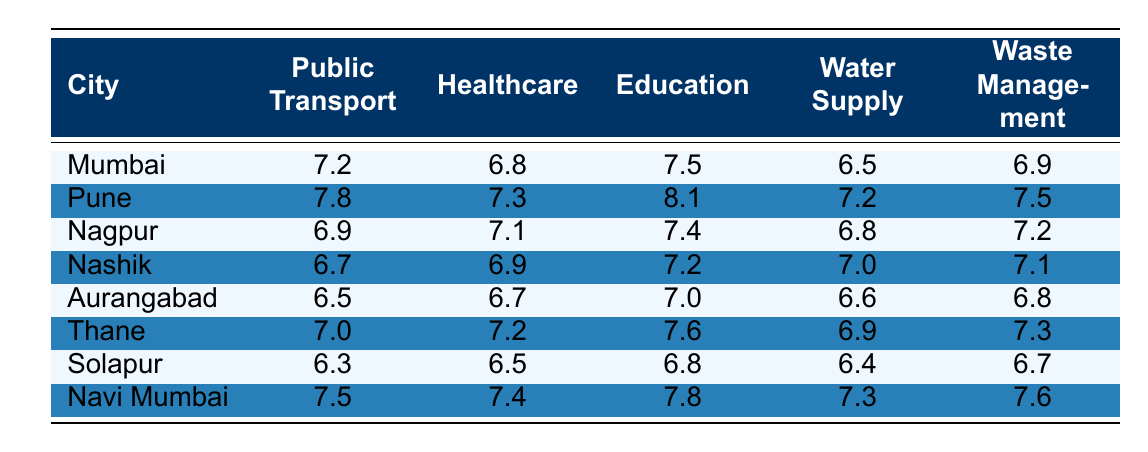What is the highest satisfaction rating for Public Transport among the cities? Looking at the "Public Transport" column, Pune has the highest score of 7.8.
Answer: Pune: 7.8 Which city has the lowest satisfaction rating for Waste Management? In the "Waste Management" column, Solapur has the lowest score of 6.3.
Answer: Solapur: 6.3 What is the average rating for Education across all cities? Adding the ratings for Education (7.5 + 8.1 + 7.4 + 7.2 + 7.0 + 7.6 + 6.8 + 7.8 = 59.6) and dividing by 8 gives an average of 59.6 / 8 = 7.45.
Answer: 7.45 Is the rating for Healthcare in Nashik more than that in Nagpur? Nashik's Healthcare rating is 6.9 while Nagpur's is 7.1, so Nashik's rating is not more than Nagpur's.
Answer: No Which city has the closest ratings for both Education and Water Supply? Checking the "Education" and "Water Supply" columns, Aurangabad has ratings of 7.0 and 6.6 respectively, while Nashik has 7.2 and 7.0. Nashik's ratings are closer together at a difference of only 0.2.
Answer: Nashik Which city has a higher rating for Healthcare, Thane or Navi Mumbai? Thane's Healthcare rating is 7.2 while Navi Mumbai's Healthcare rating is 7.4. Navi Mumbai has a higher rating.
Answer: Navi Mumbai What is the difference between the highest and lowest ratings in Public Transport? The highest rating is Pune's 7.8 and the lowest is Solapur's 6.3. The difference is 7.8 - 6.3 = 1.5.
Answer: 1.5 Which public service received the highest overall rating in Pune? In Pune, Education received the highest rating of 8.1 among all public services.
Answer: Education: 8.1 